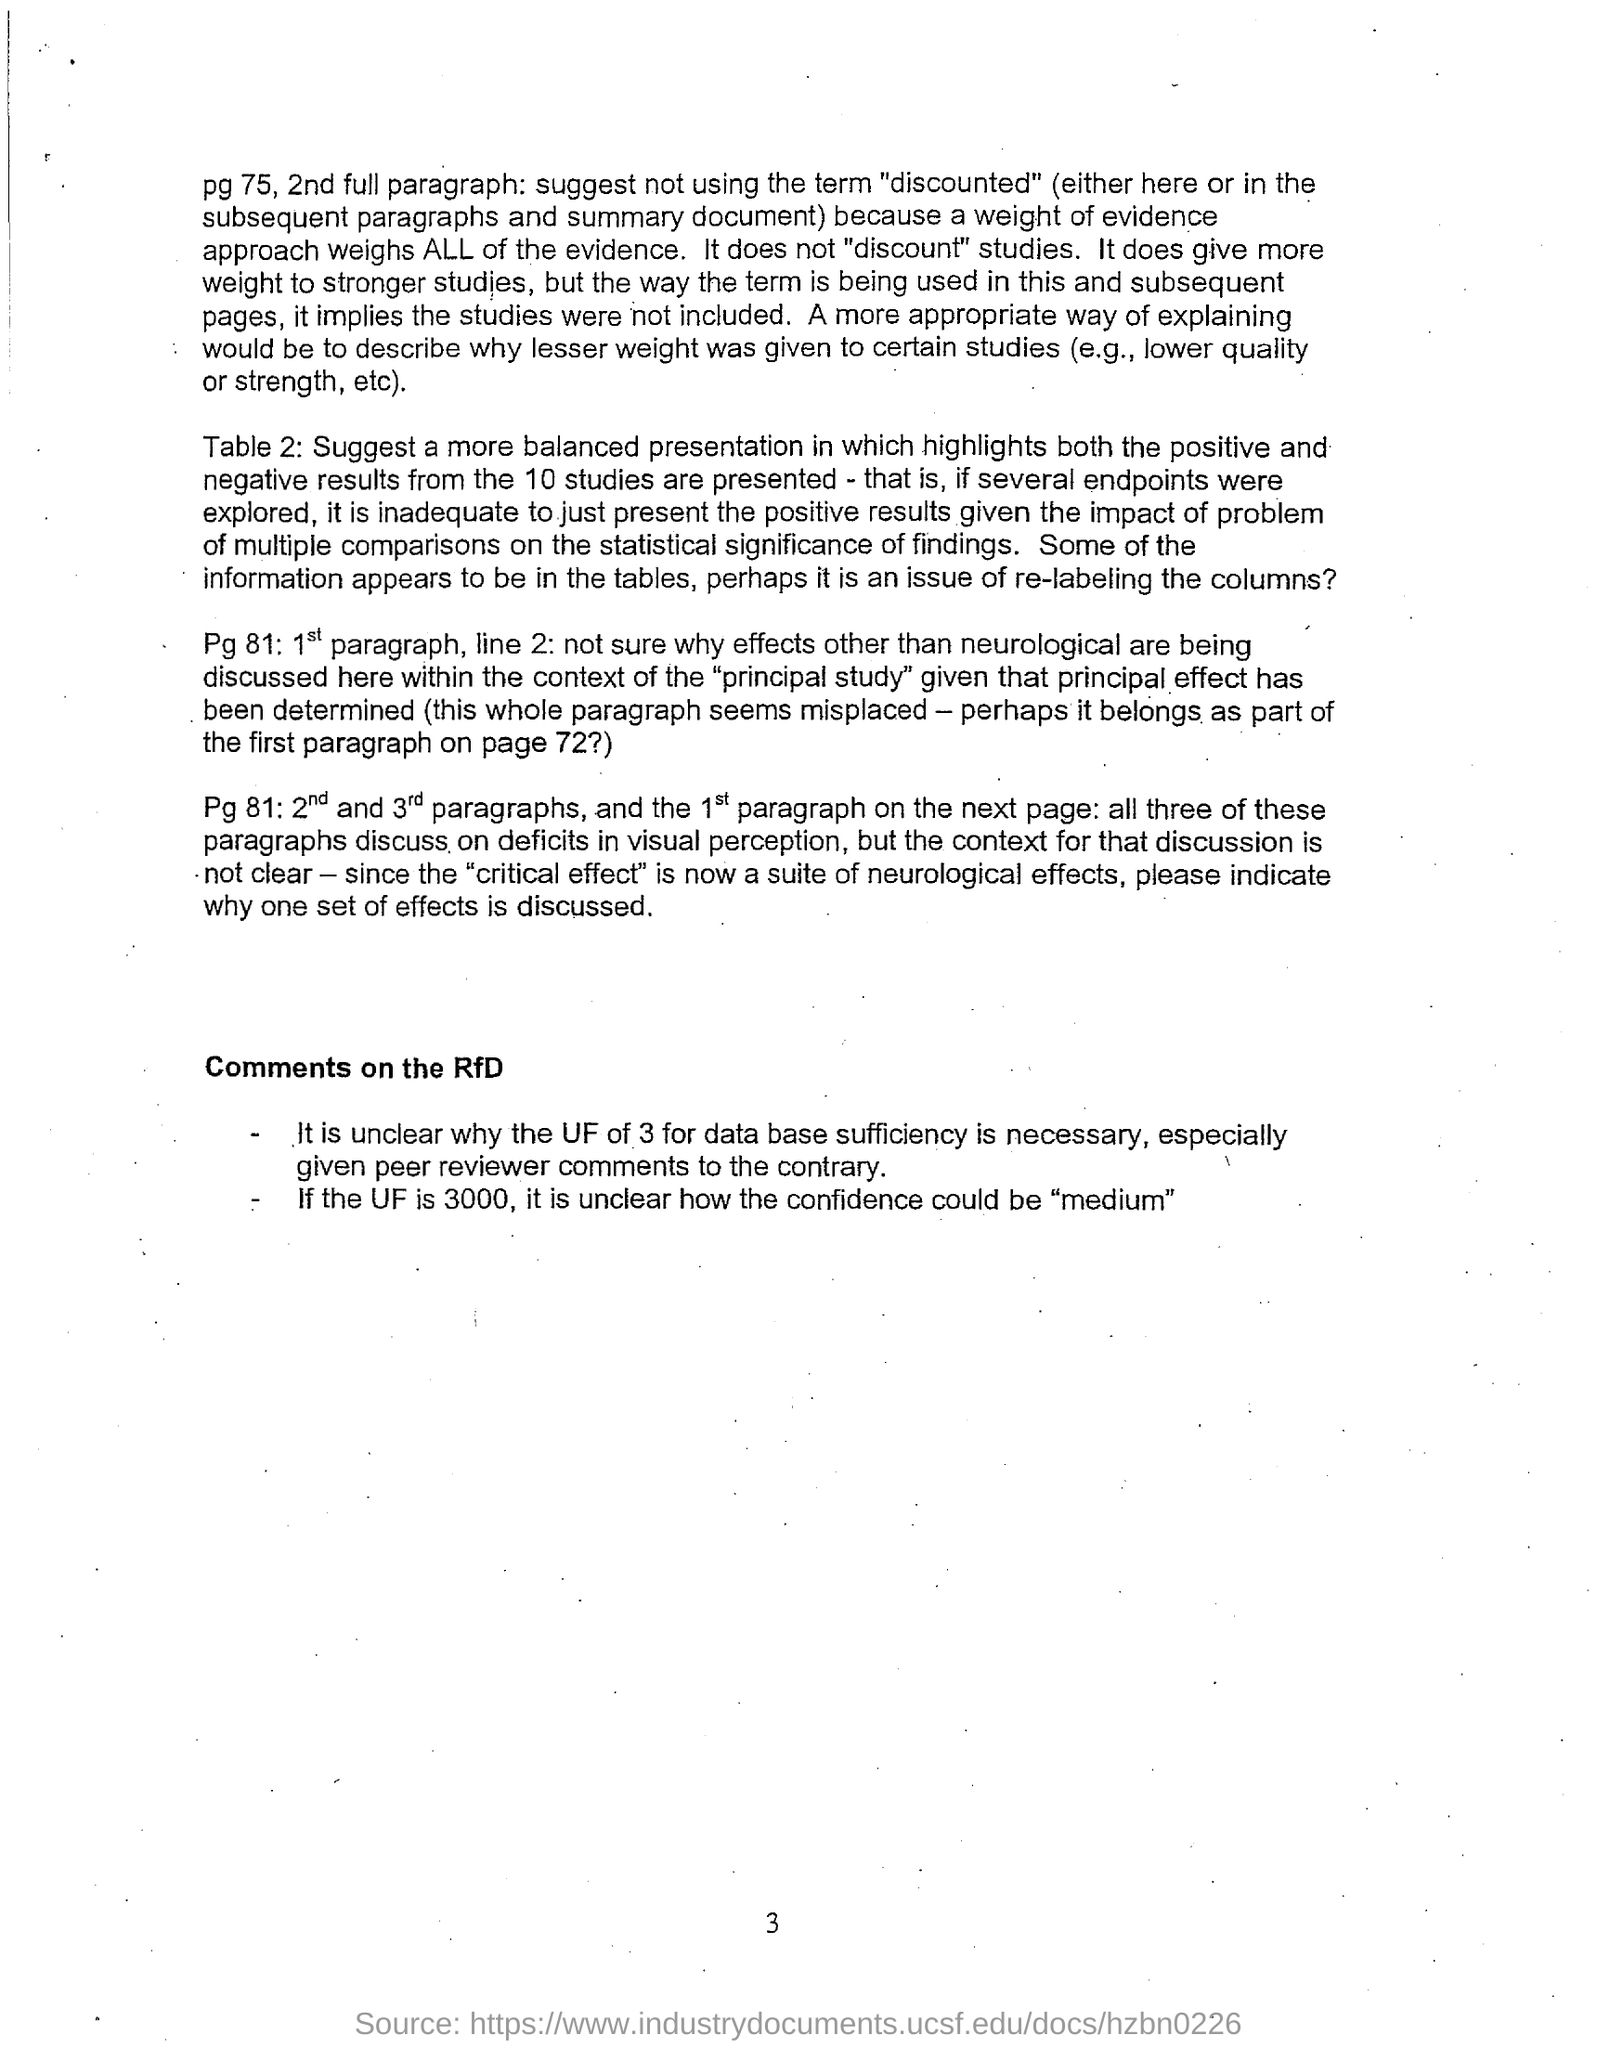What is the page no mentioned in this document?
Provide a short and direct response. 3. What is the subheading mentioned in this document?
Provide a succinct answer. Comments on the RfD. What does Pg 81: 2nd and 3rd paragraphs, and the 1st paragraph on the next page discuss about?
Give a very brief answer. All three of these paragraphs discuss on deficits in visual perception. 